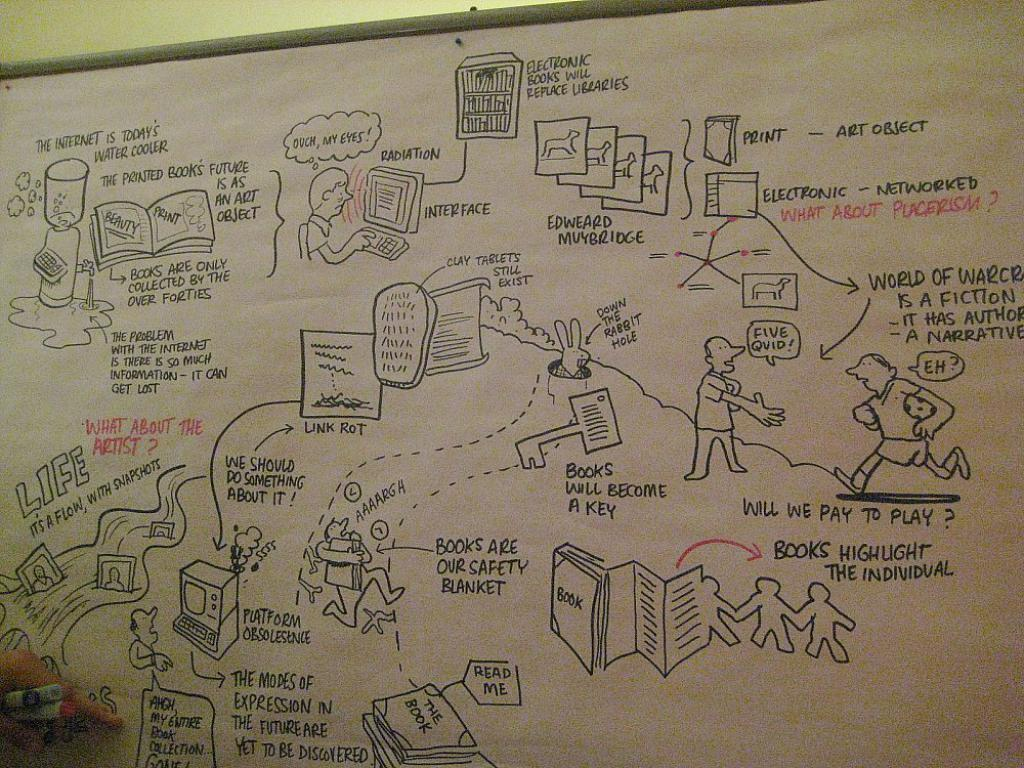<image>
Render a clear and concise summary of the photo. A cartoonish diagram is on a board and one of the dialog bubbles says "five quid!". 